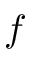Convert formula to latex. <formula><loc_0><loc_0><loc_500><loc_500>f</formula> 